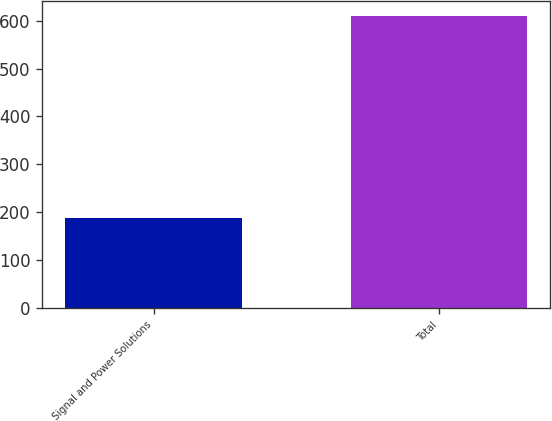Convert chart. <chart><loc_0><loc_0><loc_500><loc_500><bar_chart><fcel>Signal and Power Solutions<fcel>Total<nl><fcel>188<fcel>610<nl></chart> 